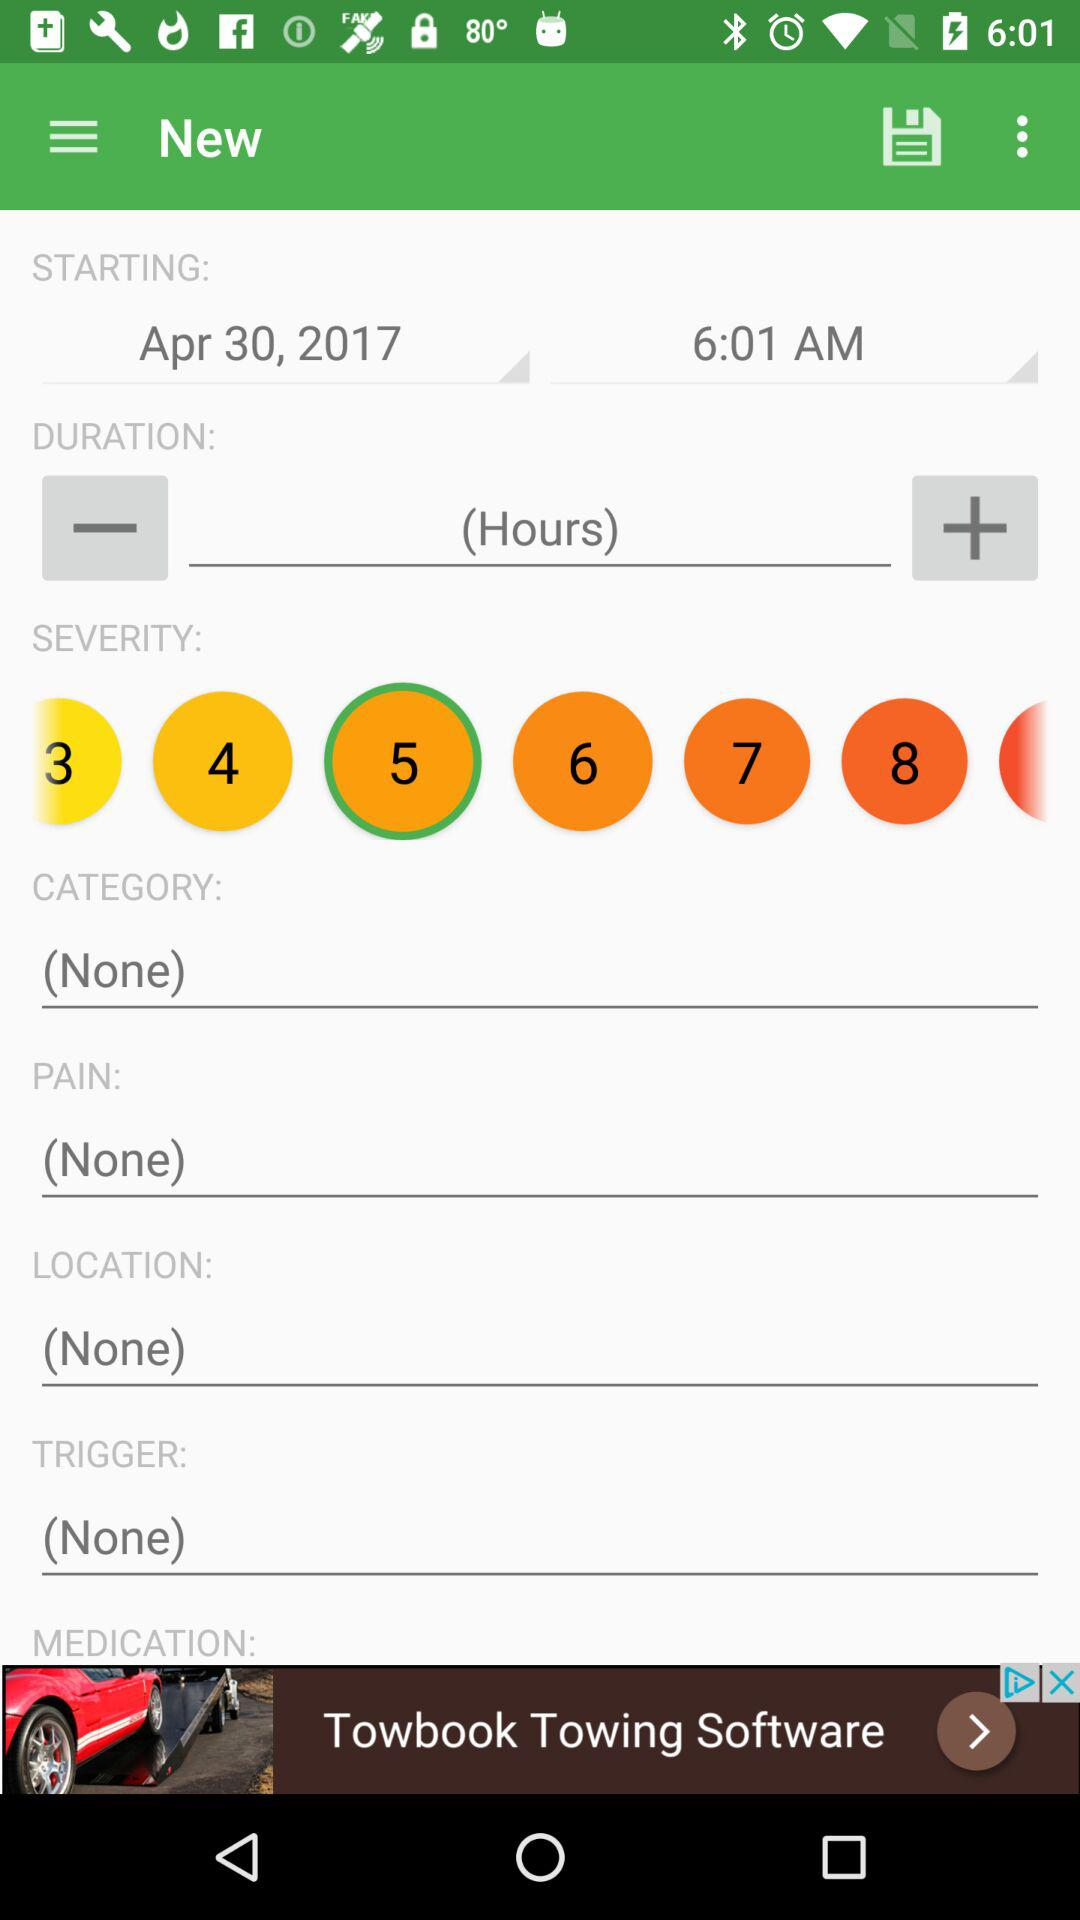What is the starting time? The starting time is 6:01 a.m. 